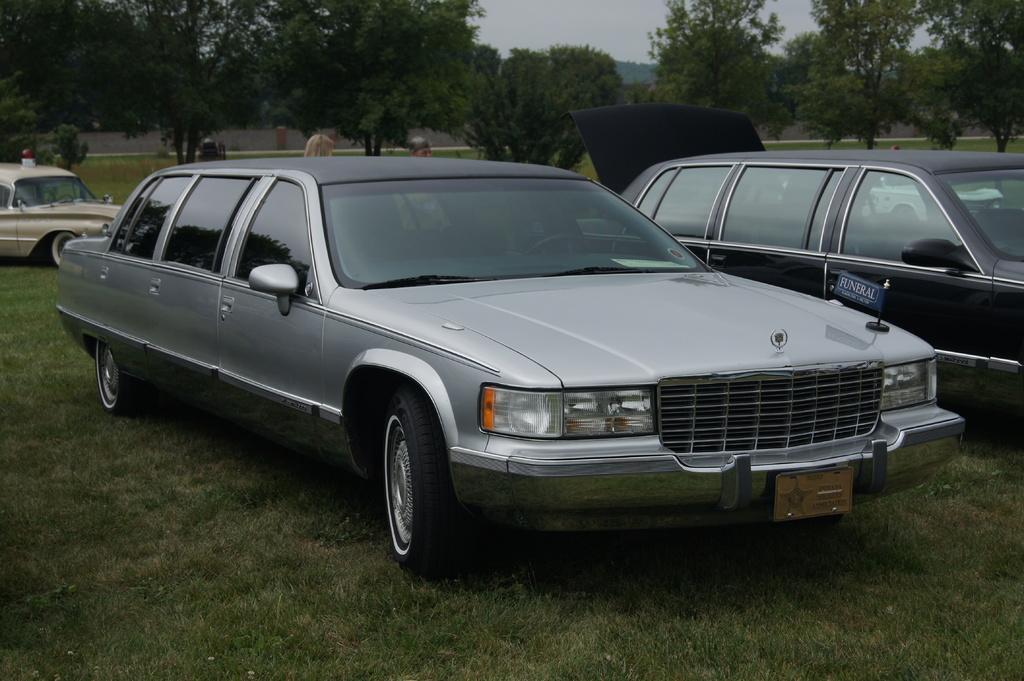Could you give a brief overview of what you see in this image? This picture shows few cars and we see trees and grass on the ground and we see car's trunk is opened and a cloudy Sky. 